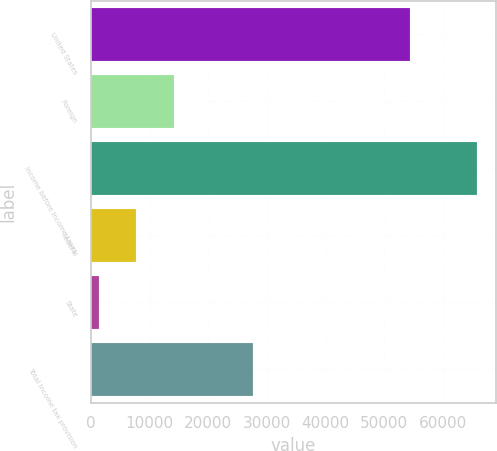Convert chart. <chart><loc_0><loc_0><loc_500><loc_500><bar_chart><fcel>United States<fcel>Foreign<fcel>Income before income taxes<fcel>Federal<fcel>State<fcel>Total income tax provision<nl><fcel>54406<fcel>14194.8<fcel>65838<fcel>7739.4<fcel>1284<fcel>27691<nl></chart> 